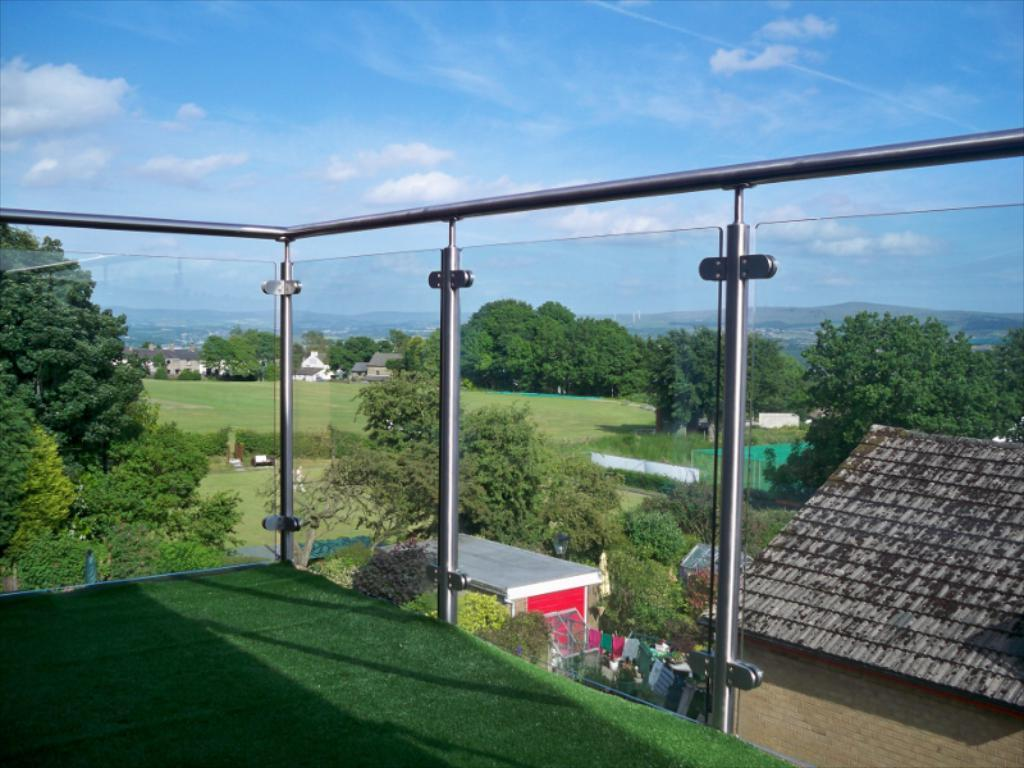What type of location is shown in the image? The image depicts a corridor of a building. What can be seen from the corridor? Buildings, trees, plants, mountains, and the sky are visible from the corridor. What type of bed can be seen in the image? There is no bed present in the image; it depicts a corridor of a building. How many bulbs are visible in the image? There is no mention of bulbs in the provided facts, so it cannot be determined how many, if any, are visible in the image. 